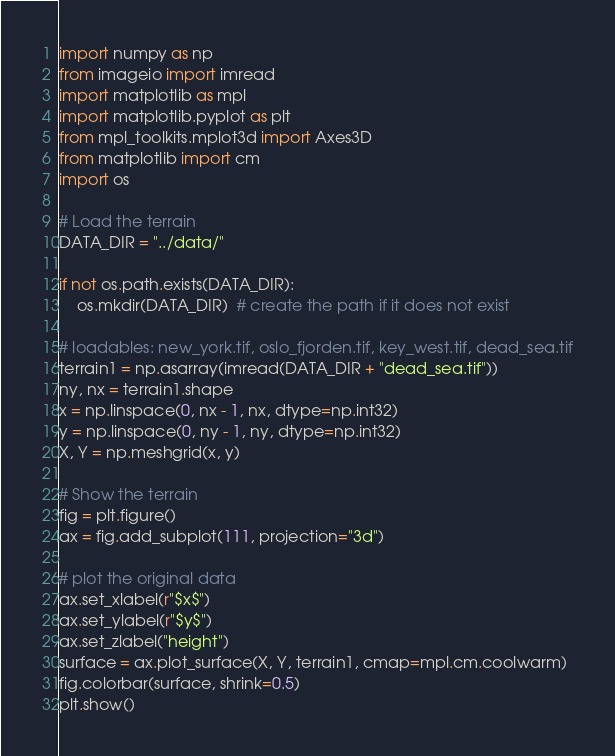<code> <loc_0><loc_0><loc_500><loc_500><_Python_>import numpy as np
from imageio import imread
import matplotlib as mpl
import matplotlib.pyplot as plt
from mpl_toolkits.mplot3d import Axes3D
from matplotlib import cm
import os

# Load the terrain
DATA_DIR = "../data/"

if not os.path.exists(DATA_DIR):
    os.mkdir(DATA_DIR)  # create the path if it does not exist

# loadables: new_york.tif, oslo_fjorden.tif, key_west.tif, dead_sea.tif
terrain1 = np.asarray(imread(DATA_DIR + "dead_sea.tif"))
ny, nx = terrain1.shape
x = np.linspace(0, nx - 1, nx, dtype=np.int32)
y = np.linspace(0, ny - 1, ny, dtype=np.int32)
X, Y = np.meshgrid(x, y)

# Show the terrain
fig = plt.figure()
ax = fig.add_subplot(111, projection="3d")

# plot the original data
ax.set_xlabel(r"$x$")
ax.set_ylabel(r"$y$")
ax.set_zlabel("height")
surface = ax.plot_surface(X, Y, terrain1, cmap=mpl.cm.coolwarm)
fig.colorbar(surface, shrink=0.5)
plt.show()
</code> 